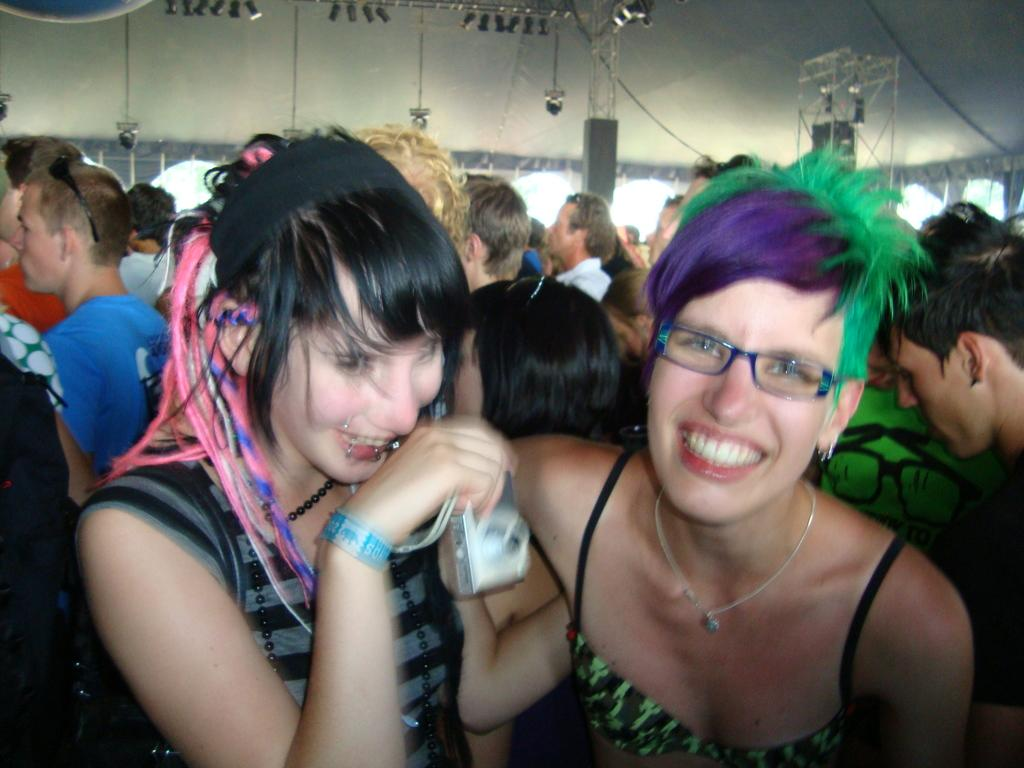What is happening in the image? There are people standing in the image. Can you describe one of the individuals in the image? There is a woman in the image. What is the woman holding in her hand? The woman is holding a camera in her hand. What type of condition is the cook experiencing in the image? There is no cook present in the image, so it is not possible to determine any condition they might be experiencing. 